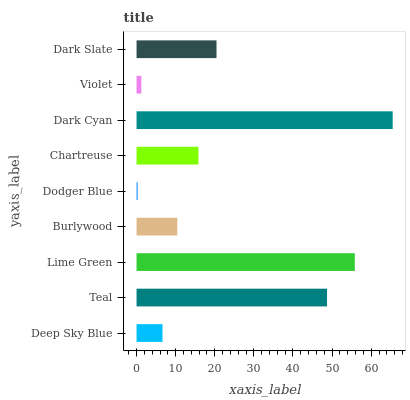Is Dodger Blue the minimum?
Answer yes or no. Yes. Is Dark Cyan the maximum?
Answer yes or no. Yes. Is Teal the minimum?
Answer yes or no. No. Is Teal the maximum?
Answer yes or no. No. Is Teal greater than Deep Sky Blue?
Answer yes or no. Yes. Is Deep Sky Blue less than Teal?
Answer yes or no. Yes. Is Deep Sky Blue greater than Teal?
Answer yes or no. No. Is Teal less than Deep Sky Blue?
Answer yes or no. No. Is Chartreuse the high median?
Answer yes or no. Yes. Is Chartreuse the low median?
Answer yes or no. Yes. Is Lime Green the high median?
Answer yes or no. No. Is Violet the low median?
Answer yes or no. No. 